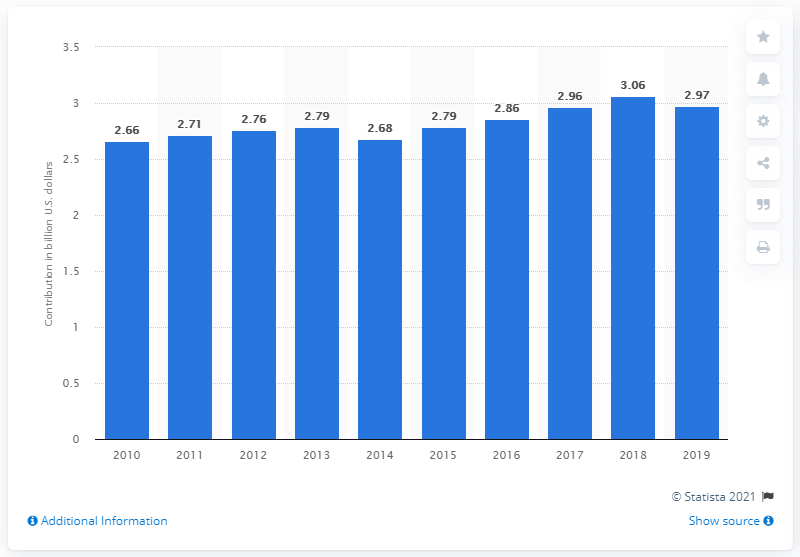Mention a couple of crucial points in this snapshot. In 2018, tourism contributed 2.97 billion US dollars to Cuba's Gross Domestic Product. In 2019, the Cuban travel and tourism sector contributed 2.97% to the country's GDP. 